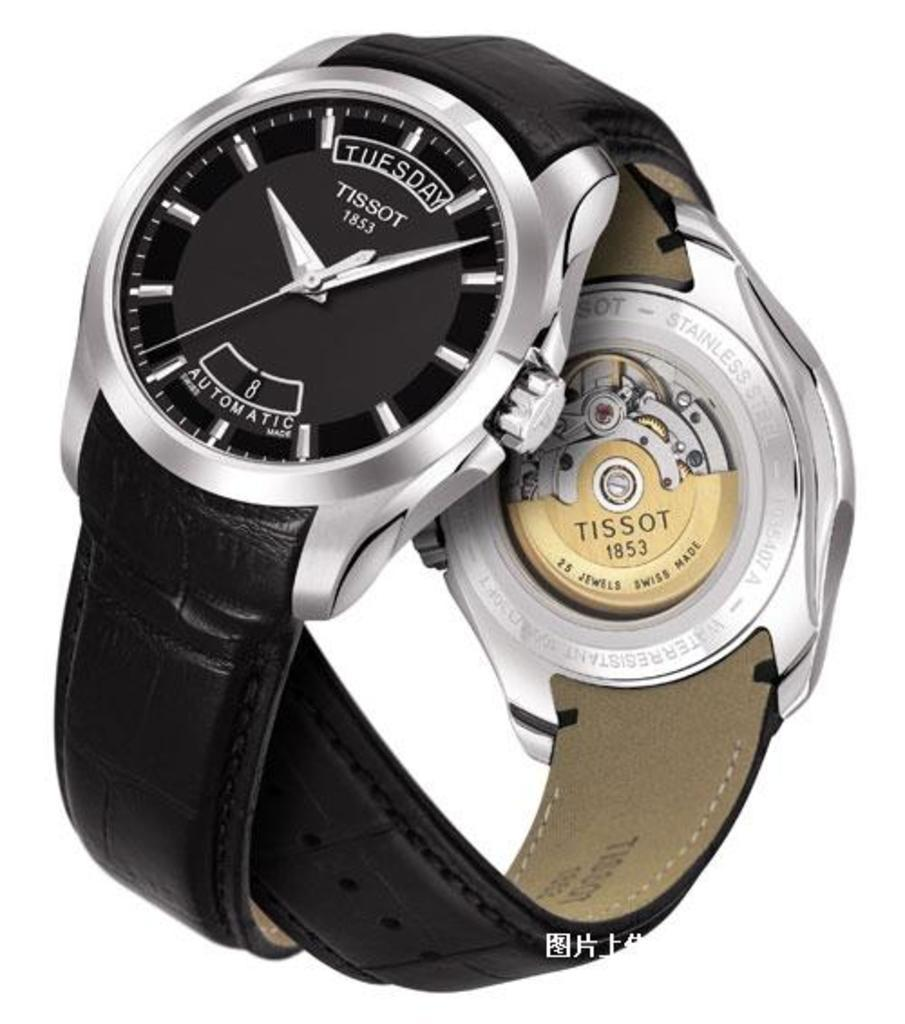Provide a one-sentence caption for the provided image. Two gorgeous blackTissot watches intertwined with each other. 